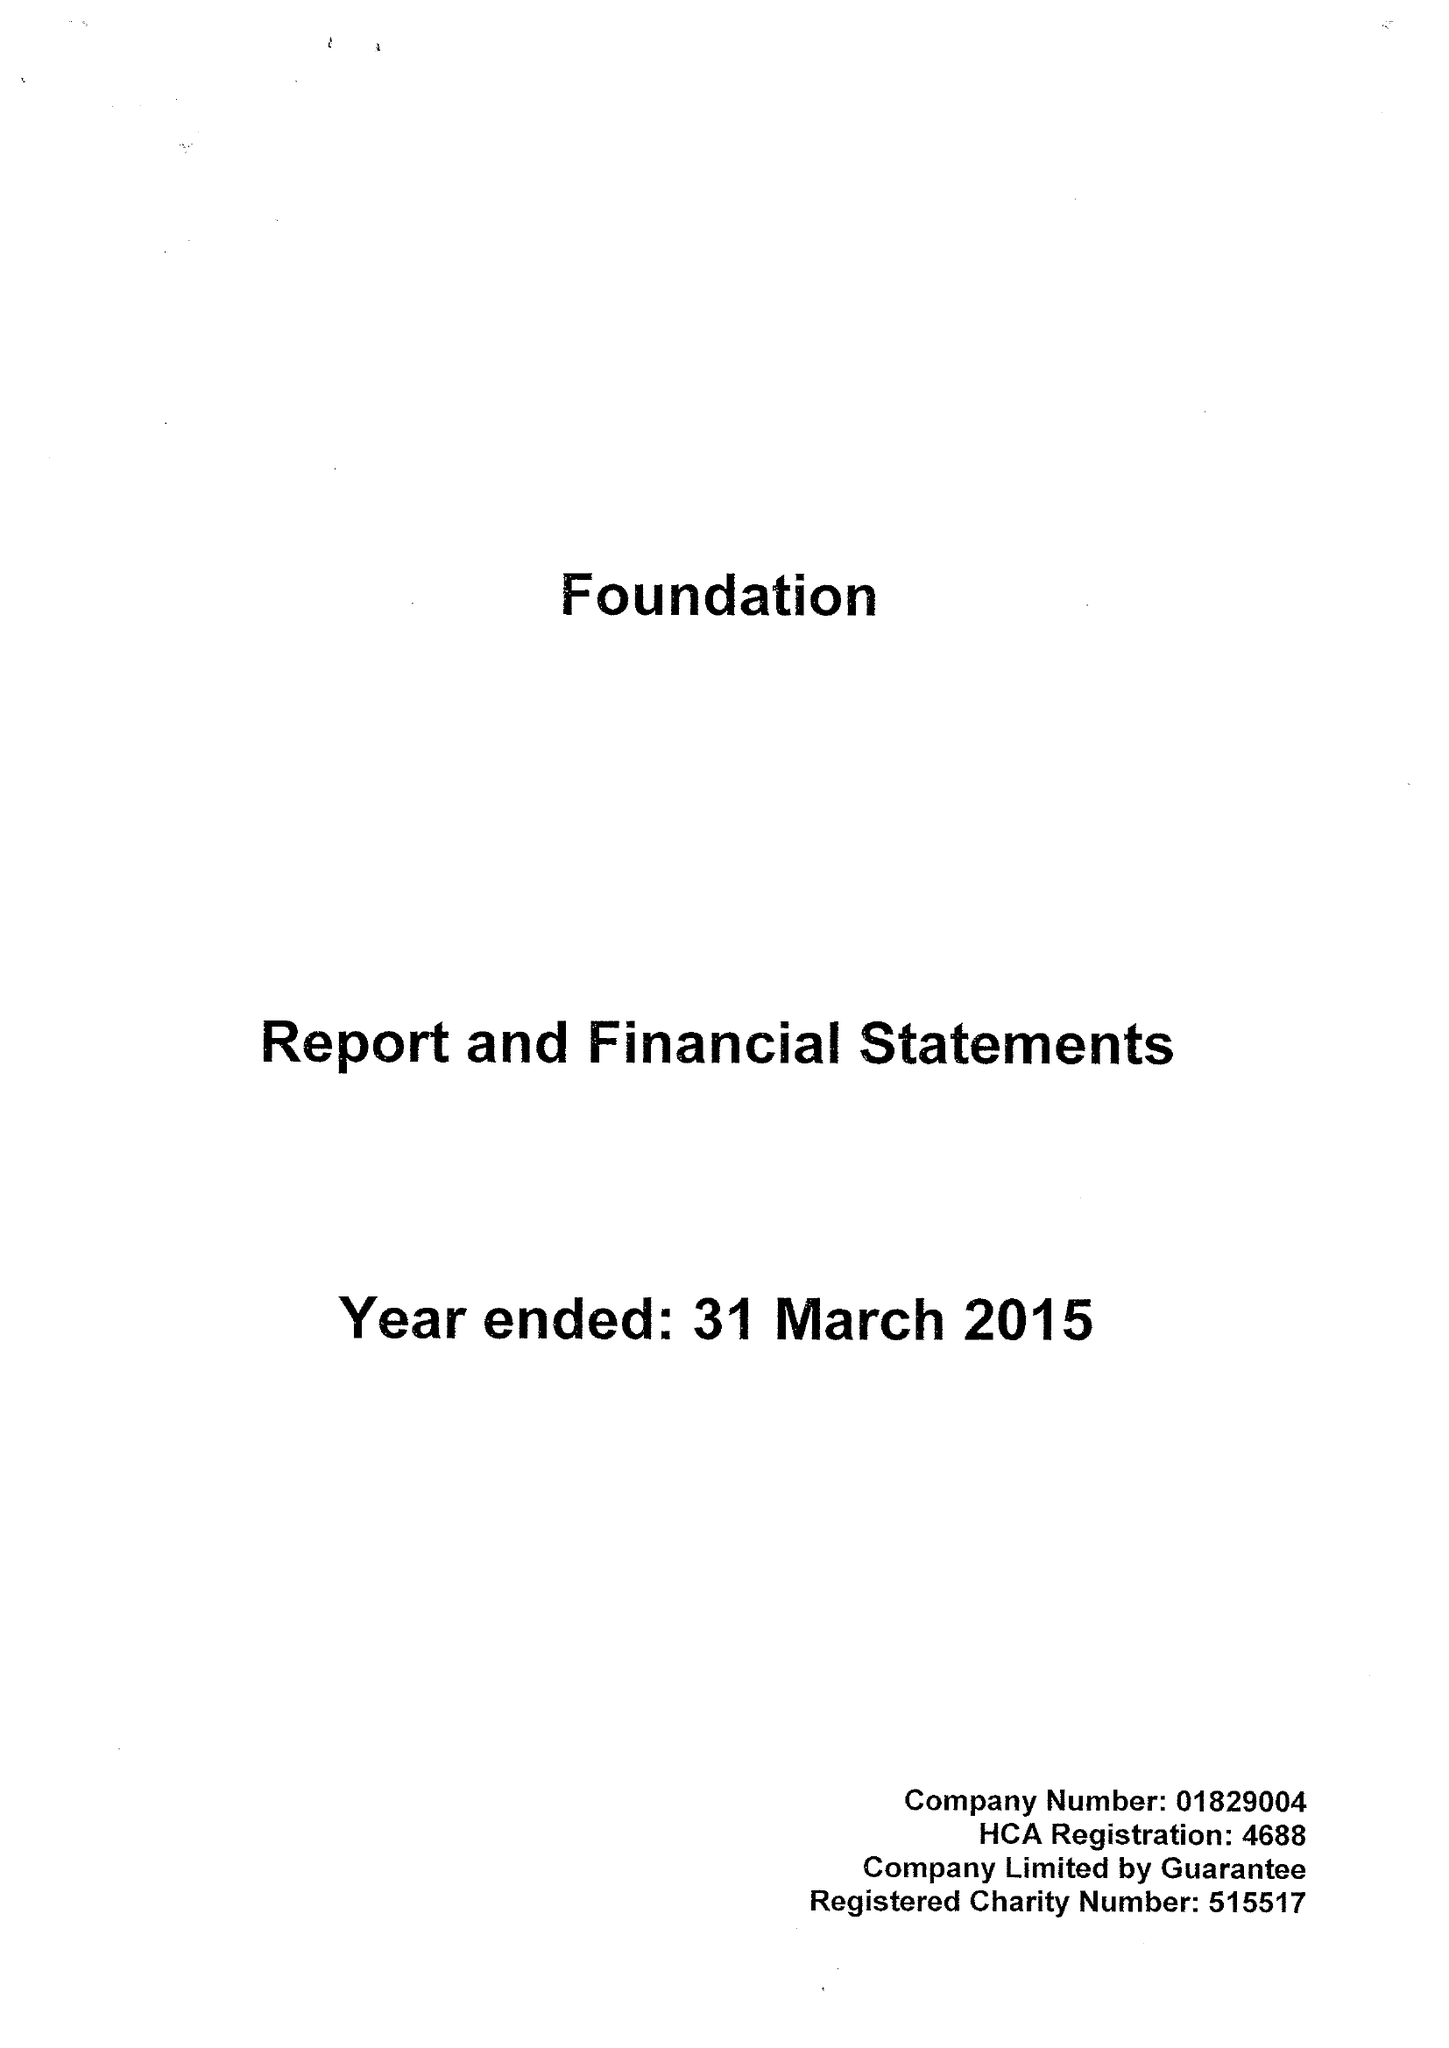What is the value for the spending_annually_in_british_pounds?
Answer the question using a single word or phrase. 14213000.00 